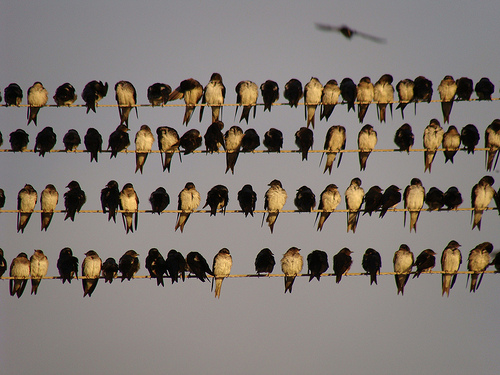<image>
Is there a bird on the wire? Yes. Looking at the image, I can see the bird is positioned on top of the wire, with the wire providing support. Is there a bird to the right of the bird? No. The bird is not to the right of the bird. The horizontal positioning shows a different relationship. Is the bird in front of the bird? No. The bird is not in front of the bird. The spatial positioning shows a different relationship between these objects. 